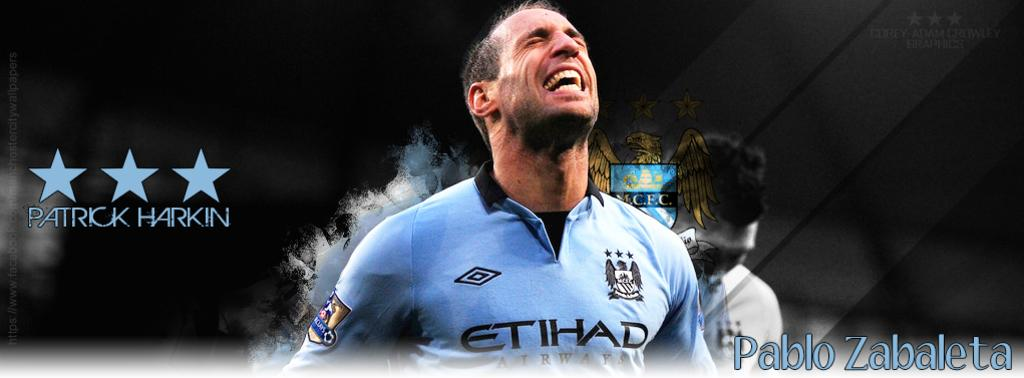Provide a one-sentence caption for the provided image. An Argentine soccer player named Pablo Zabaleta looks up with aspiration during a game. 